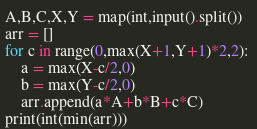Convert code to text. <code><loc_0><loc_0><loc_500><loc_500><_Python_>A,B,C,X,Y = map(int,input().split())
arr = []
for c in range(0,max(X+1,Y+1)*2,2): 
    a = max(X-c/2,0)
    b = max(Y-c/2,0)
    arr.append(a*A+b*B+c*C)
print(int(min(arr)))</code> 